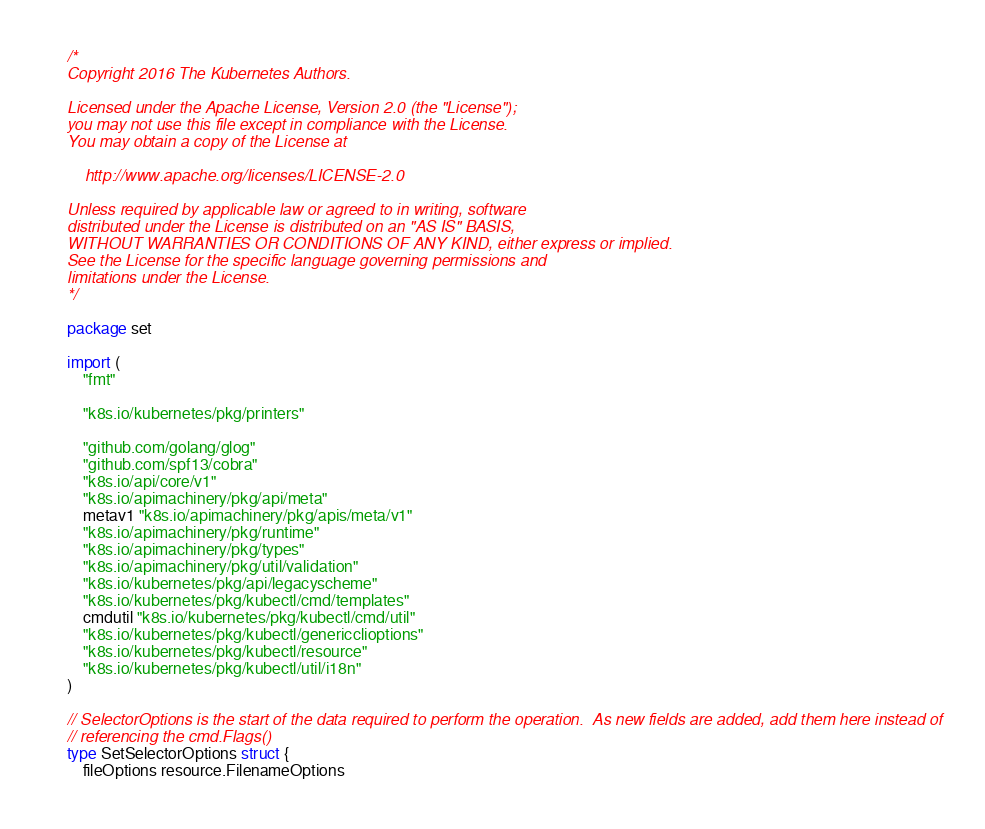Convert code to text. <code><loc_0><loc_0><loc_500><loc_500><_Go_>/*
Copyright 2016 The Kubernetes Authors.

Licensed under the Apache License, Version 2.0 (the "License");
you may not use this file except in compliance with the License.
You may obtain a copy of the License at

    http://www.apache.org/licenses/LICENSE-2.0

Unless required by applicable law or agreed to in writing, software
distributed under the License is distributed on an "AS IS" BASIS,
WITHOUT WARRANTIES OR CONDITIONS OF ANY KIND, either express or implied.
See the License for the specific language governing permissions and
limitations under the License.
*/

package set

import (
	"fmt"

	"k8s.io/kubernetes/pkg/printers"

	"github.com/golang/glog"
	"github.com/spf13/cobra"
	"k8s.io/api/core/v1"
	"k8s.io/apimachinery/pkg/api/meta"
	metav1 "k8s.io/apimachinery/pkg/apis/meta/v1"
	"k8s.io/apimachinery/pkg/runtime"
	"k8s.io/apimachinery/pkg/types"
	"k8s.io/apimachinery/pkg/util/validation"
	"k8s.io/kubernetes/pkg/api/legacyscheme"
	"k8s.io/kubernetes/pkg/kubectl/cmd/templates"
	cmdutil "k8s.io/kubernetes/pkg/kubectl/cmd/util"
	"k8s.io/kubernetes/pkg/kubectl/genericclioptions"
	"k8s.io/kubernetes/pkg/kubectl/resource"
	"k8s.io/kubernetes/pkg/kubectl/util/i18n"
)

// SelectorOptions is the start of the data required to perform the operation.  As new fields are added, add them here instead of
// referencing the cmd.Flags()
type SetSelectorOptions struct {
	fileOptions resource.FilenameOptions
</code> 